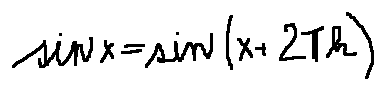Convert formula to latex. <formula><loc_0><loc_0><loc_500><loc_500>\sin x = \sin ( x + 2 \pi k )</formula> 